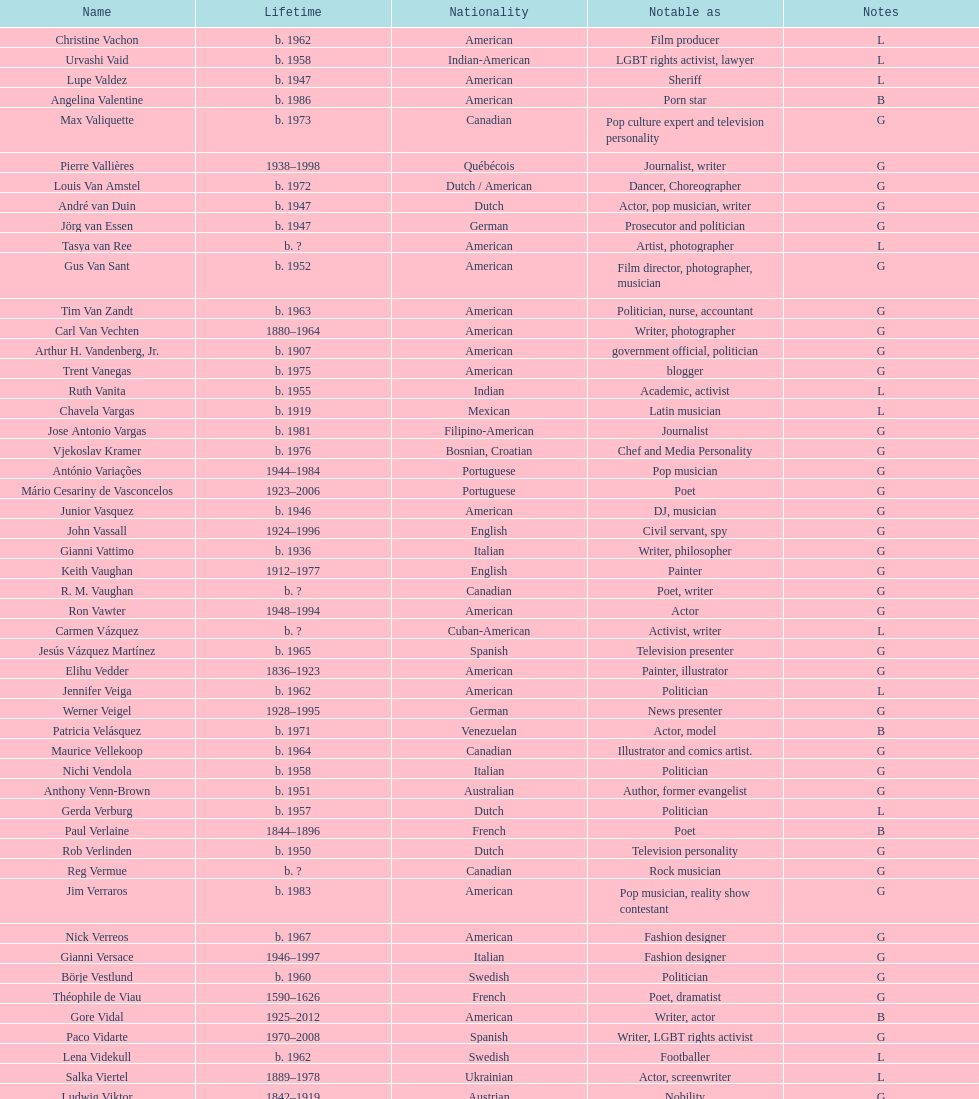Which nation has the most significant number of people linked to it? American. 